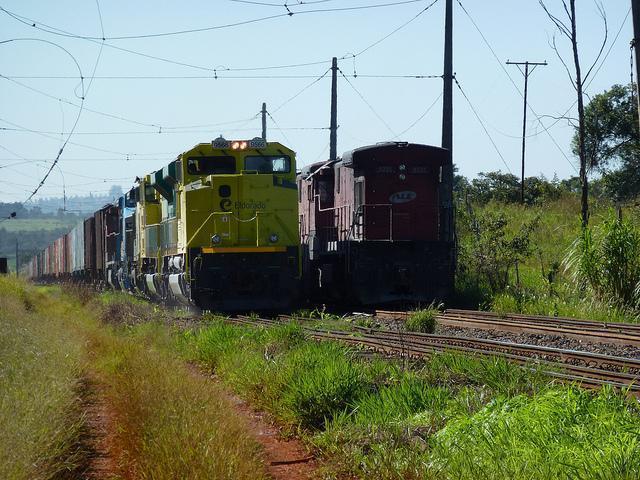How many train tracks are shown?
Give a very brief answer. 2. How many trains can you see?
Give a very brief answer. 2. 